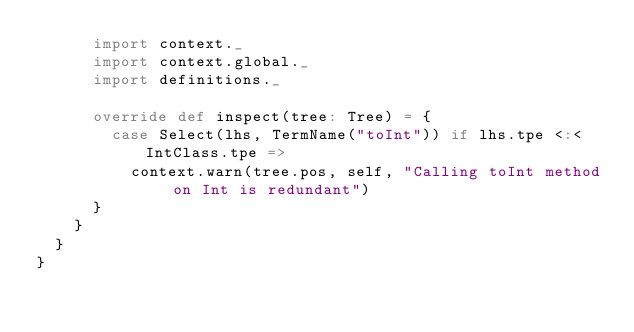Convert code to text. <code><loc_0><loc_0><loc_500><loc_500><_Scala_>      import context._
      import context.global._
      import definitions._

      override def inspect(tree: Tree) = {
        case Select(lhs, TermName("toInt")) if lhs.tpe <:< IntClass.tpe =>
          context.warn(tree.pos, self, "Calling toInt method on Int is redundant")
      }
    }
  }
}
</code> 